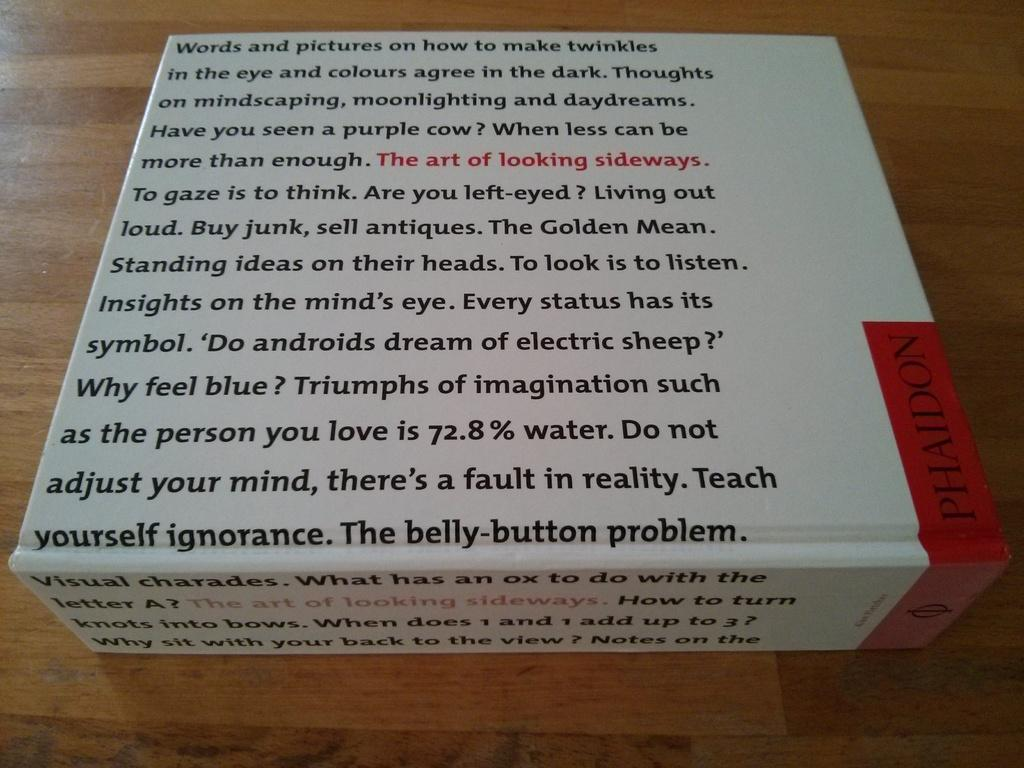<image>
Share a concise interpretation of the image provided. A box covered in writing ends with the words The belly button problem. 